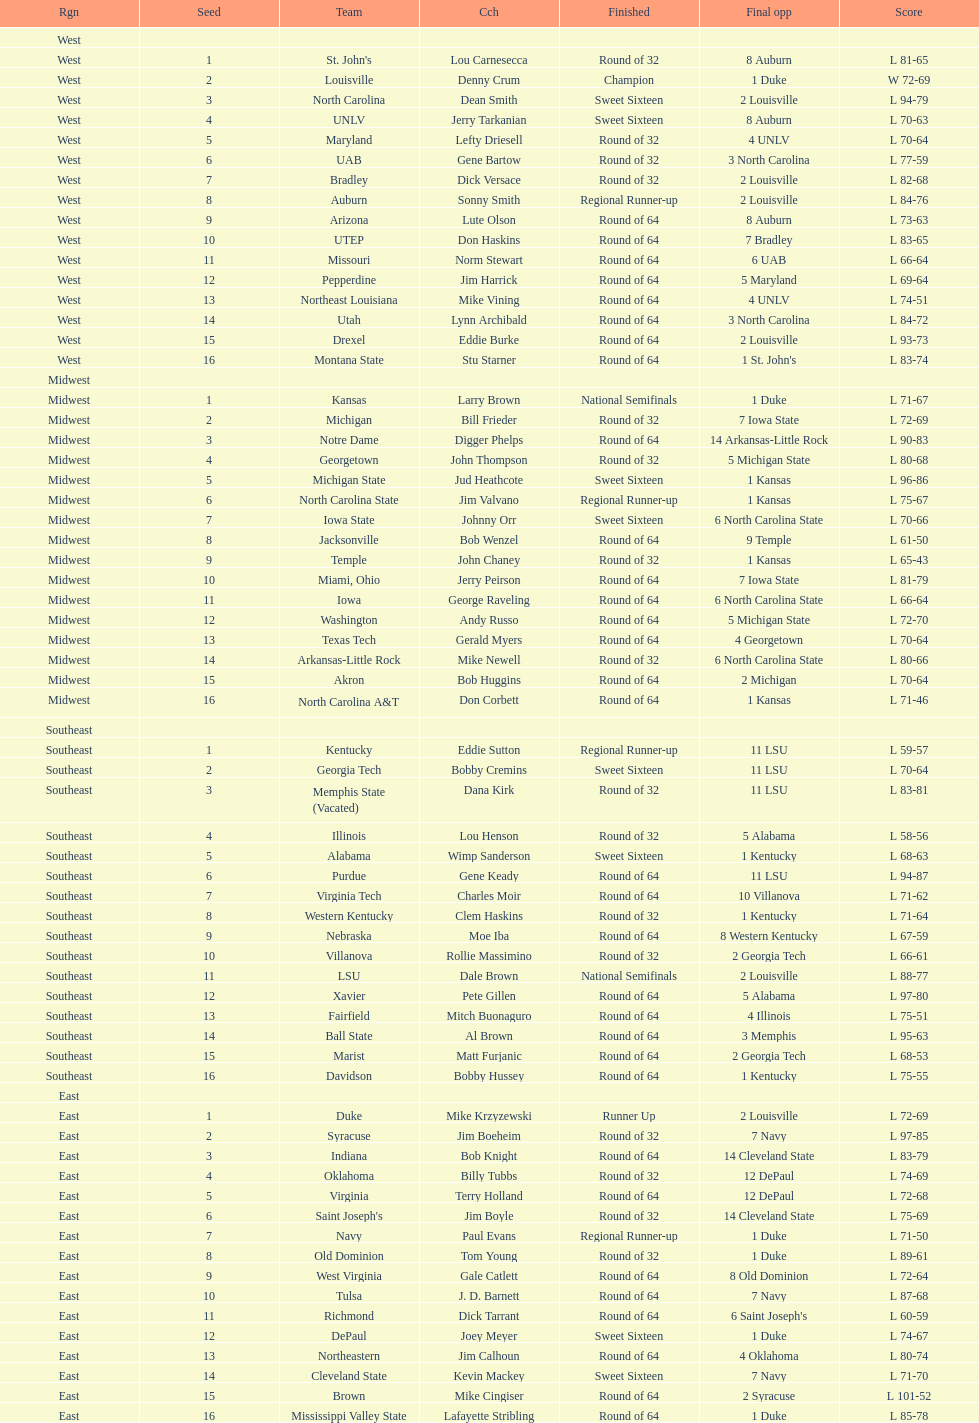What region is listed before the midwest? West. 